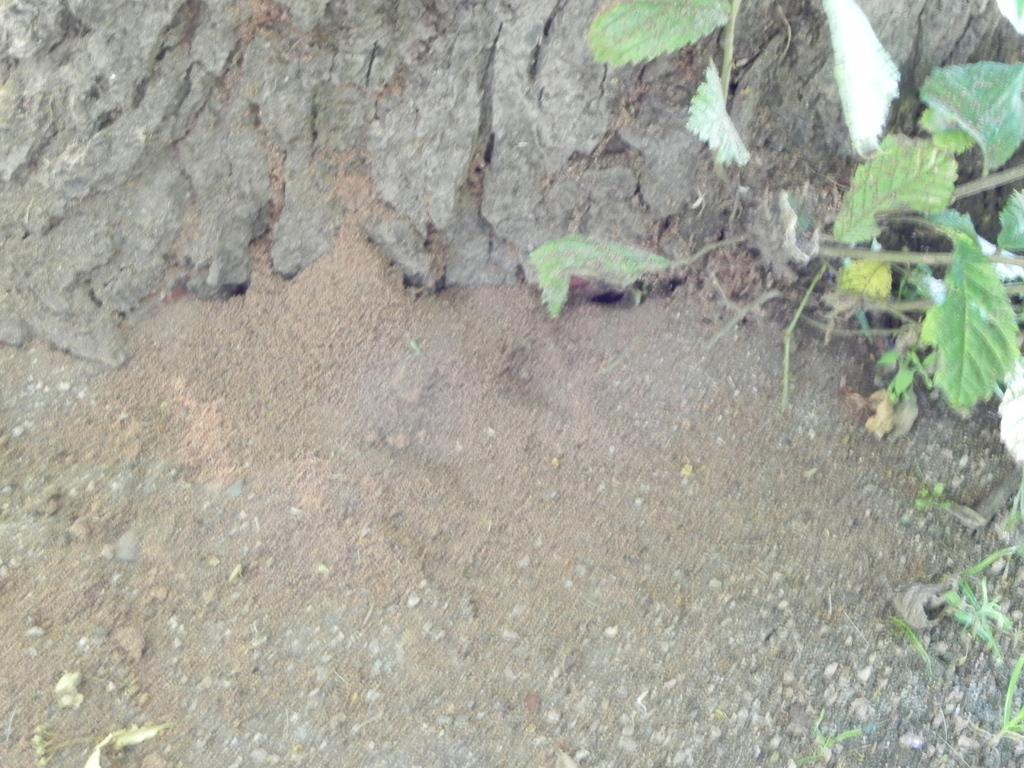Where was the image taken from? The image is taken from outside the city. What can be seen in the right corner of the image? There is a plant with green leaves in the right corner of the image. What type of terrain is visible in the background of the image? There is land visible in the background of the image. What can be observed on the land in the background? There are stones present on the land in the background. How many women are visible in the image? There are no women present in the image. What type of prison can be seen in the image? There is no prison present in the image. 